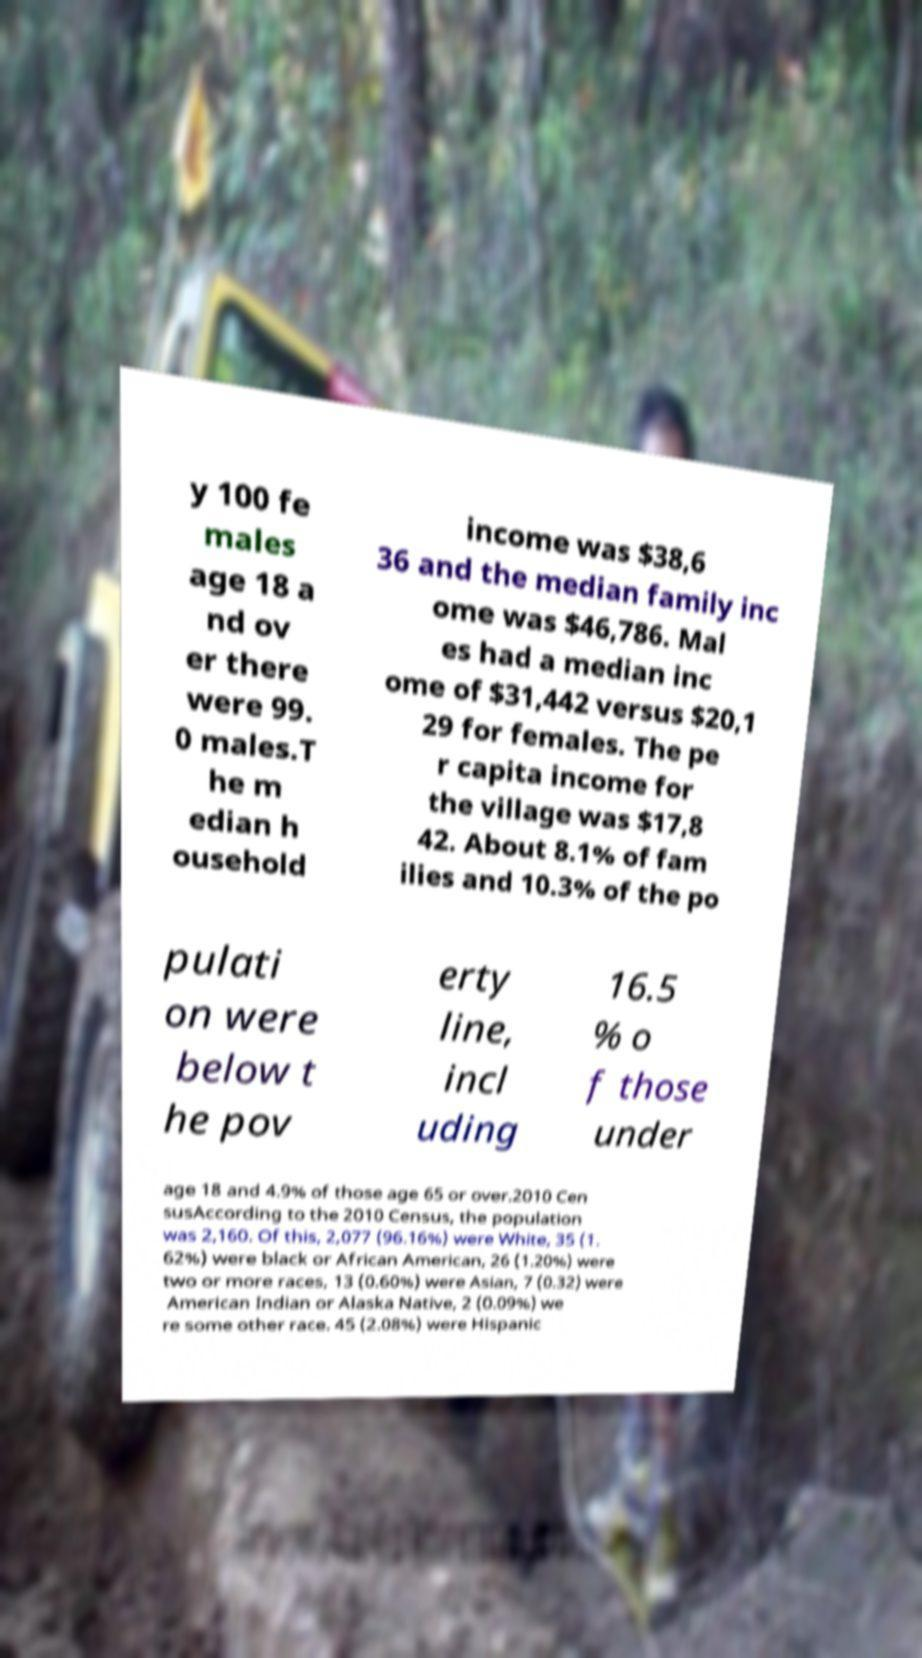Please read and relay the text visible in this image. What does it say? y 100 fe males age 18 a nd ov er there were 99. 0 males.T he m edian h ousehold income was $38,6 36 and the median family inc ome was $46,786. Mal es had a median inc ome of $31,442 versus $20,1 29 for females. The pe r capita income for the village was $17,8 42. About 8.1% of fam ilies and 10.3% of the po pulati on were below t he pov erty line, incl uding 16.5 % o f those under age 18 and 4.9% of those age 65 or over.2010 Cen susAccording to the 2010 Census, the population was 2,160. Of this, 2,077 (96.16%) were White, 35 (1. 62%) were black or African American, 26 (1.20%) were two or more races, 13 (0.60%) were Asian, 7 (0.32) were American Indian or Alaska Native, 2 (0.09%) we re some other race. 45 (2.08%) were Hispanic 